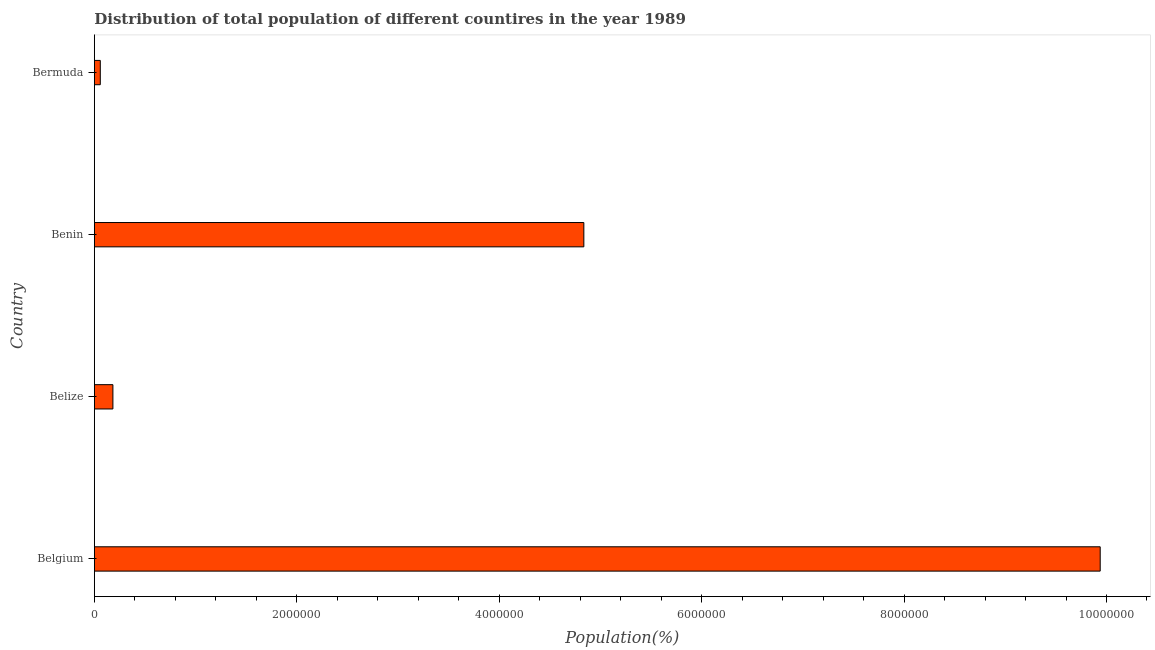Does the graph contain grids?
Keep it short and to the point. No. What is the title of the graph?
Your response must be concise. Distribution of total population of different countires in the year 1989. What is the label or title of the X-axis?
Make the answer very short. Population(%). What is the label or title of the Y-axis?
Your answer should be compact. Country. What is the population in Bermuda?
Keep it short and to the point. 5.88e+04. Across all countries, what is the maximum population?
Ensure brevity in your answer.  9.94e+06. Across all countries, what is the minimum population?
Give a very brief answer. 5.88e+04. In which country was the population maximum?
Your answer should be very brief. Belgium. In which country was the population minimum?
Your answer should be compact. Bermuda. What is the sum of the population?
Keep it short and to the point. 1.50e+07. What is the difference between the population in Benin and Bermuda?
Ensure brevity in your answer.  4.78e+06. What is the average population per country?
Keep it short and to the point. 3.75e+06. What is the median population?
Provide a short and direct response. 2.51e+06. In how many countries, is the population greater than 4800000 %?
Your answer should be very brief. 2. What is the ratio of the population in Belgium to that in Bermuda?
Offer a terse response. 168.89. Is the difference between the population in Belize and Bermuda greater than the difference between any two countries?
Ensure brevity in your answer.  No. What is the difference between the highest and the second highest population?
Make the answer very short. 5.10e+06. What is the difference between the highest and the lowest population?
Keep it short and to the point. 9.88e+06. How many bars are there?
Your answer should be very brief. 4. Are all the bars in the graph horizontal?
Your response must be concise. Yes. How many countries are there in the graph?
Provide a succinct answer. 4. What is the Population(%) of Belgium?
Offer a terse response. 9.94e+06. What is the Population(%) of Belize?
Ensure brevity in your answer.  1.83e+05. What is the Population(%) in Benin?
Offer a terse response. 4.84e+06. What is the Population(%) in Bermuda?
Ensure brevity in your answer.  5.88e+04. What is the difference between the Population(%) in Belgium and Belize?
Make the answer very short. 9.75e+06. What is the difference between the Population(%) in Belgium and Benin?
Provide a short and direct response. 5.10e+06. What is the difference between the Population(%) in Belgium and Bermuda?
Give a very brief answer. 9.88e+06. What is the difference between the Population(%) in Belize and Benin?
Give a very brief answer. -4.65e+06. What is the difference between the Population(%) in Belize and Bermuda?
Keep it short and to the point. 1.25e+05. What is the difference between the Population(%) in Benin and Bermuda?
Your response must be concise. 4.78e+06. What is the ratio of the Population(%) in Belgium to that in Belize?
Keep it short and to the point. 54.16. What is the ratio of the Population(%) in Belgium to that in Benin?
Your answer should be compact. 2.06. What is the ratio of the Population(%) in Belgium to that in Bermuda?
Ensure brevity in your answer.  168.89. What is the ratio of the Population(%) in Belize to that in Benin?
Ensure brevity in your answer.  0.04. What is the ratio of the Population(%) in Belize to that in Bermuda?
Your answer should be compact. 3.12. What is the ratio of the Population(%) in Benin to that in Bermuda?
Ensure brevity in your answer.  82.19. 